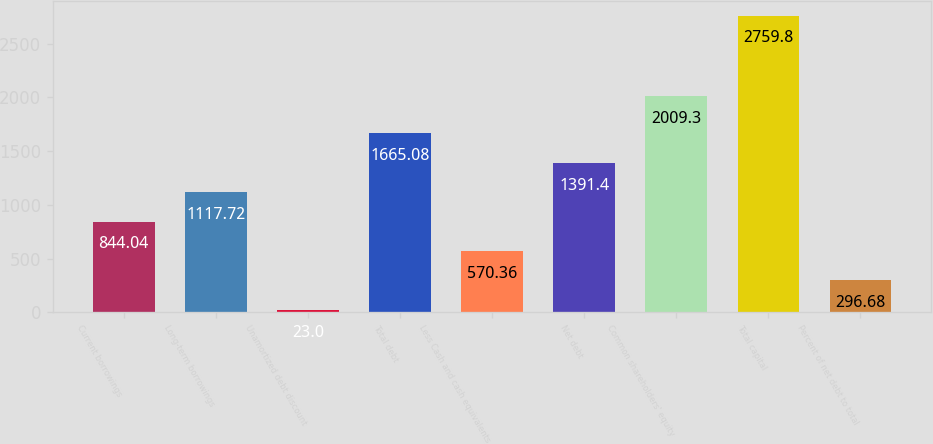<chart> <loc_0><loc_0><loc_500><loc_500><bar_chart><fcel>Current borrowings<fcel>Long-term borrowings<fcel>Unamortized debt discount<fcel>Total debt<fcel>Less Cash and cash equivalents<fcel>Net debt<fcel>Common shareholders' equity<fcel>Total capital<fcel>Percent of net debt to total<nl><fcel>844.04<fcel>1117.72<fcel>23<fcel>1665.08<fcel>570.36<fcel>1391.4<fcel>2009.3<fcel>2759.8<fcel>296.68<nl></chart> 